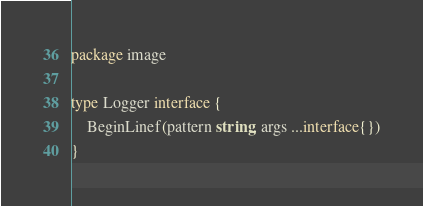<code> <loc_0><loc_0><loc_500><loc_500><_Go_>package image

type Logger interface {
	BeginLinef(pattern string, args ...interface{})
}
</code> 